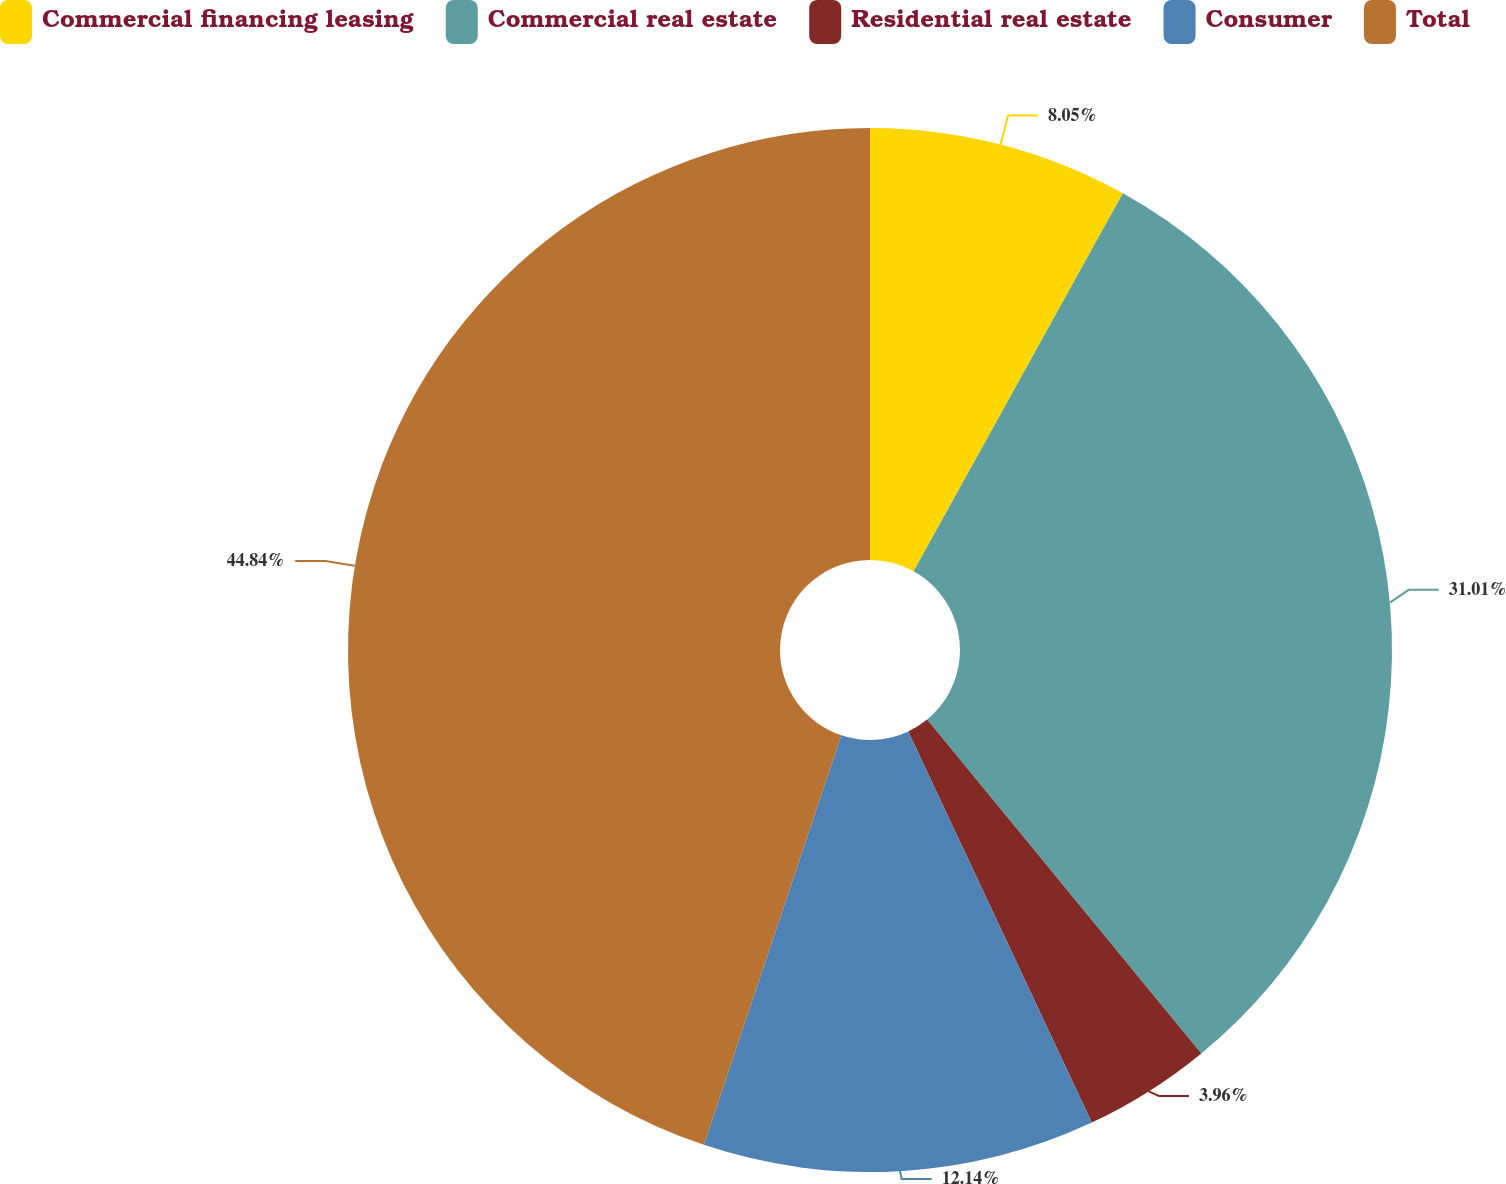<chart> <loc_0><loc_0><loc_500><loc_500><pie_chart><fcel>Commercial financing leasing<fcel>Commercial real estate<fcel>Residential real estate<fcel>Consumer<fcel>Total<nl><fcel>8.05%<fcel>31.01%<fcel>3.96%<fcel>12.14%<fcel>44.85%<nl></chart> 